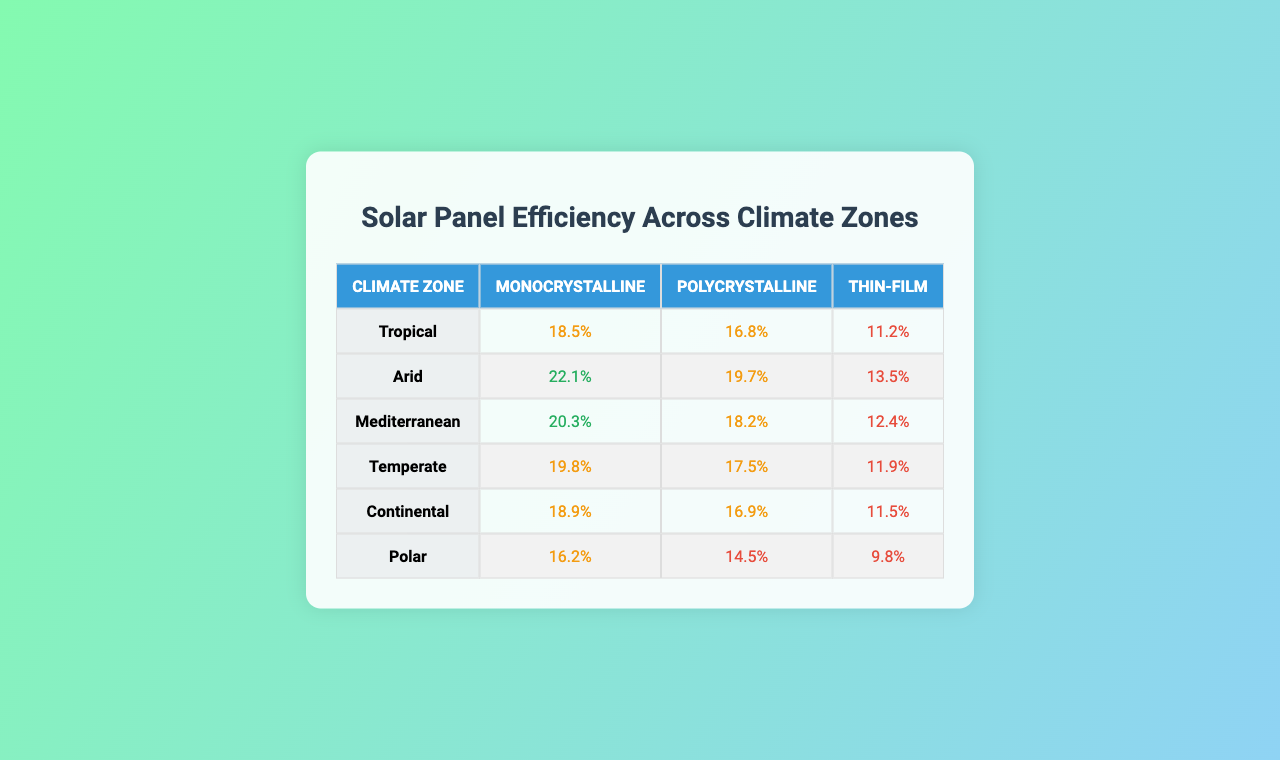What is the efficiency rate of monocrystalline solar panels in the Arid climate zone? According to the table, the efficiency rate for monocrystalline solar panels in the Arid climate zone is listed as 22.1%.
Answer: 22.1% Which solar panel type has the highest efficiency in the Mediterranean climate zone? In the Mediterranean climate zone, the monocrystalline panels have the highest efficiency rate of 20.3% compared to polycrystalline and thin-film types.
Answer: Monocrystalline What is the difference in efficiency between polycrystalline and thin-film panels in the Continental zone? The efficiency rates are 16.9% for polycrystalline and 11.5% for thin-film panels in the Continental zone. The difference is 16.9% - 11.5% = 5.4%.
Answer: 5.4% What is the average efficiency of thin-film solar panels across all climate zones? We add the thin-film efficiency rates: (11.2 + 13.5 + 12.4 + 11.9 + 11.5 + 9.8) = 69.3%. Dividing by the number of climate zones (6) gives an average of 69.3% / 6 = 11.55%.
Answer: 11.55% Is the efficiency of polycrystalline solar panels in the Temperate climate zone higher than 18%? The efficiency for polycrystalline panels in the Temperate zone is 17.5%, which is not higher than 18%. Therefore, the answer is false.
Answer: False Which climate zone has the lowest efficiency for monocrystalline solar panels? The Polar climate zone lists the lowest efficiency for monocrystalline panels at 16.2%, lower than any other climate zones.
Answer: Polar Among all types of solar panels, which has the largest efficiency percentage in the Tropical zone, and what is the value? The Tropical climate zone has monocrystalline solar panels with the largest efficiency at 18.5%, compared to the other types listed in that zone.
Answer: Monocrystalline, 18.5% What is the total efficiency of all monocrystalline solar panel types when added together? We sum the efficiencies for monocrystalline panels in all zones: (18.5 + 22.1 + 20.3 + 19.8 + 18.9 + 16.2) = 115.8%.
Answer: 115.8% Which solar panel type has the lowest efficiency in the Polar zone? In the Polar zone, the thin-film solar panels have the lowest efficiency at 9.8%, which is lower than the other types listed for that zone.
Answer: Thin-film Are the efficiency rates of polycrystalline and thin-film solar panels in the Arid zone greater than 15%? The Arid zone records 19.7% for polycrystalline and 13.5% for thin-film panels. Since 19.7% is greater than 15% but 13.5% is not, the efficiency rates are not both greater than 15%.
Answer: No 